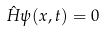Convert formula to latex. <formula><loc_0><loc_0><loc_500><loc_500>\hat { H } \psi ( x , t ) = 0</formula> 